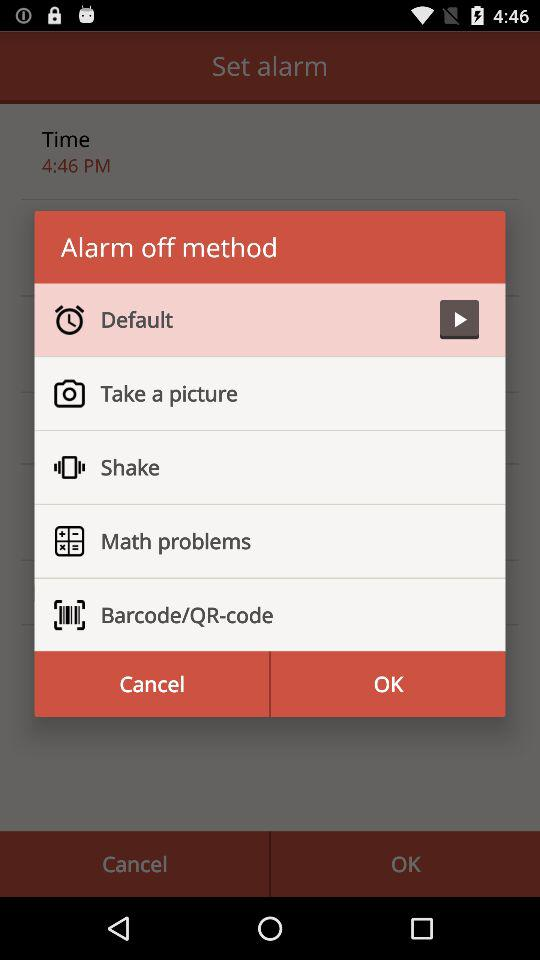At what time is the alarm set? The alarm is set for 4:46 PM. 